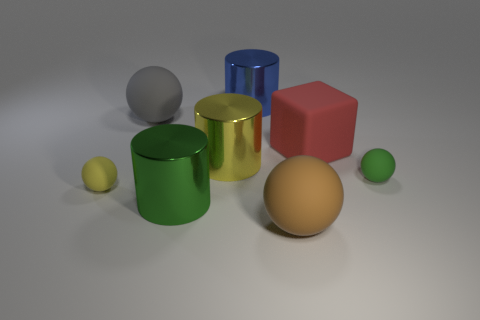Subtract all gray spheres. How many spheres are left? 3 Subtract all green balls. How many balls are left? 3 Add 1 blue metallic objects. How many objects exist? 9 Subtract 2 spheres. How many spheres are left? 2 Subtract all red balls. Subtract all red cubes. How many balls are left? 4 Subtract 0 red cylinders. How many objects are left? 8 Subtract all blocks. How many objects are left? 7 Subtract all green metal cylinders. Subtract all large metal things. How many objects are left? 4 Add 4 big yellow shiny objects. How many big yellow shiny objects are left? 5 Add 3 tiny gray matte blocks. How many tiny gray matte blocks exist? 3 